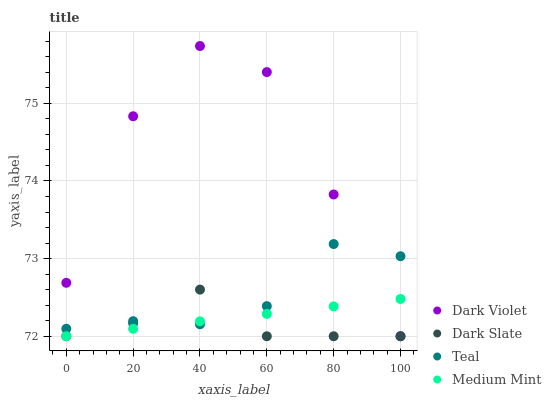Does Dark Slate have the minimum area under the curve?
Answer yes or no. Yes. Does Dark Violet have the maximum area under the curve?
Answer yes or no. Yes. Does Teal have the minimum area under the curve?
Answer yes or no. No. Does Teal have the maximum area under the curve?
Answer yes or no. No. Is Medium Mint the smoothest?
Answer yes or no. Yes. Is Dark Violet the roughest?
Answer yes or no. Yes. Is Dark Slate the smoothest?
Answer yes or no. No. Is Dark Slate the roughest?
Answer yes or no. No. Does Medium Mint have the lowest value?
Answer yes or no. Yes. Does Teal have the lowest value?
Answer yes or no. No. Does Dark Violet have the highest value?
Answer yes or no. Yes. Does Dark Slate have the highest value?
Answer yes or no. No. Does Dark Violet intersect Teal?
Answer yes or no. Yes. Is Dark Violet less than Teal?
Answer yes or no. No. Is Dark Violet greater than Teal?
Answer yes or no. No. 